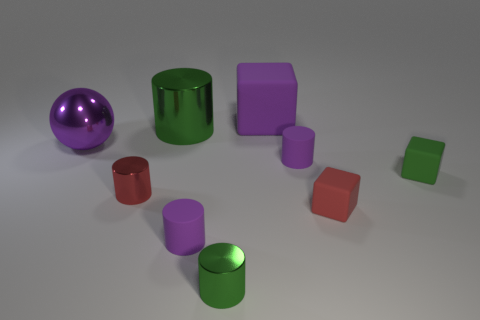Subtract all red shiny cylinders. How many cylinders are left? 4 Subtract all purple cylinders. How many cylinders are left? 3 Subtract 0 cyan cylinders. How many objects are left? 9 Subtract all cylinders. How many objects are left? 4 Subtract 5 cylinders. How many cylinders are left? 0 Subtract all brown cubes. Subtract all red cylinders. How many cubes are left? 3 Subtract all brown balls. How many cyan cylinders are left? 0 Subtract all big cyan cubes. Subtract all red metal objects. How many objects are left? 8 Add 8 tiny red rubber cubes. How many tiny red rubber cubes are left? 9 Add 1 green spheres. How many green spheres exist? 1 